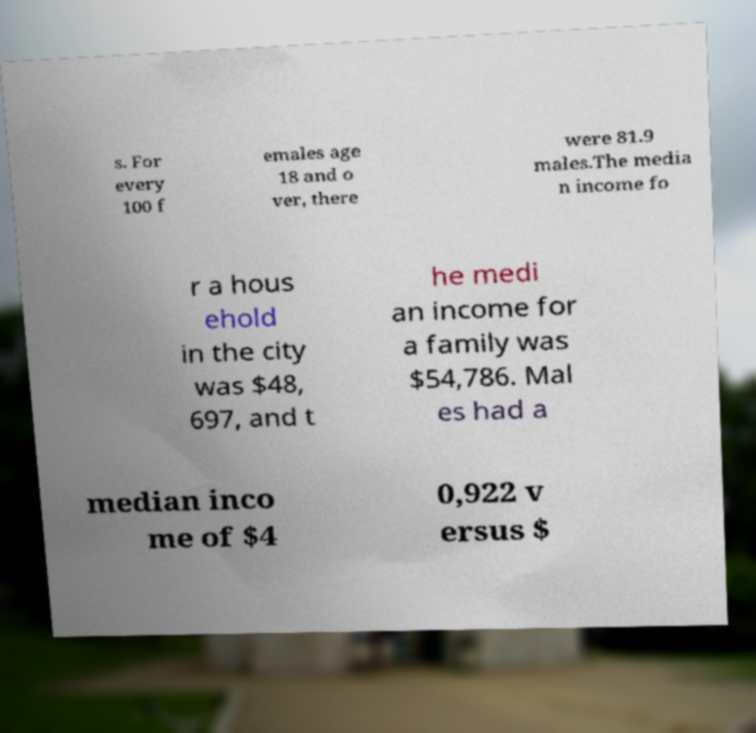There's text embedded in this image that I need extracted. Can you transcribe it verbatim? s. For every 100 f emales age 18 and o ver, there were 81.9 males.The media n income fo r a hous ehold in the city was $48, 697, and t he medi an income for a family was $54,786. Mal es had a median inco me of $4 0,922 v ersus $ 